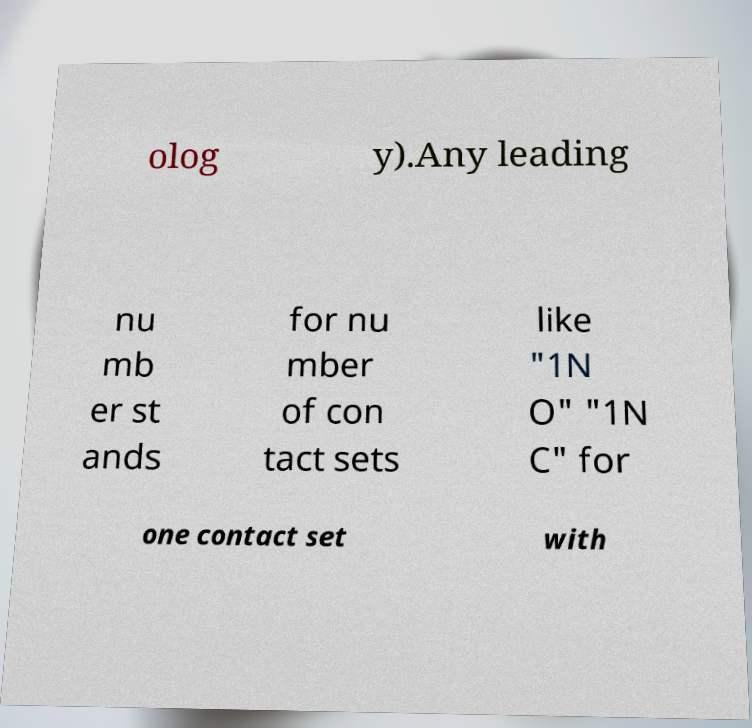What messages or text are displayed in this image? I need them in a readable, typed format. olog y).Any leading nu mb er st ands for nu mber of con tact sets like "1N O" "1N C" for one contact set with 